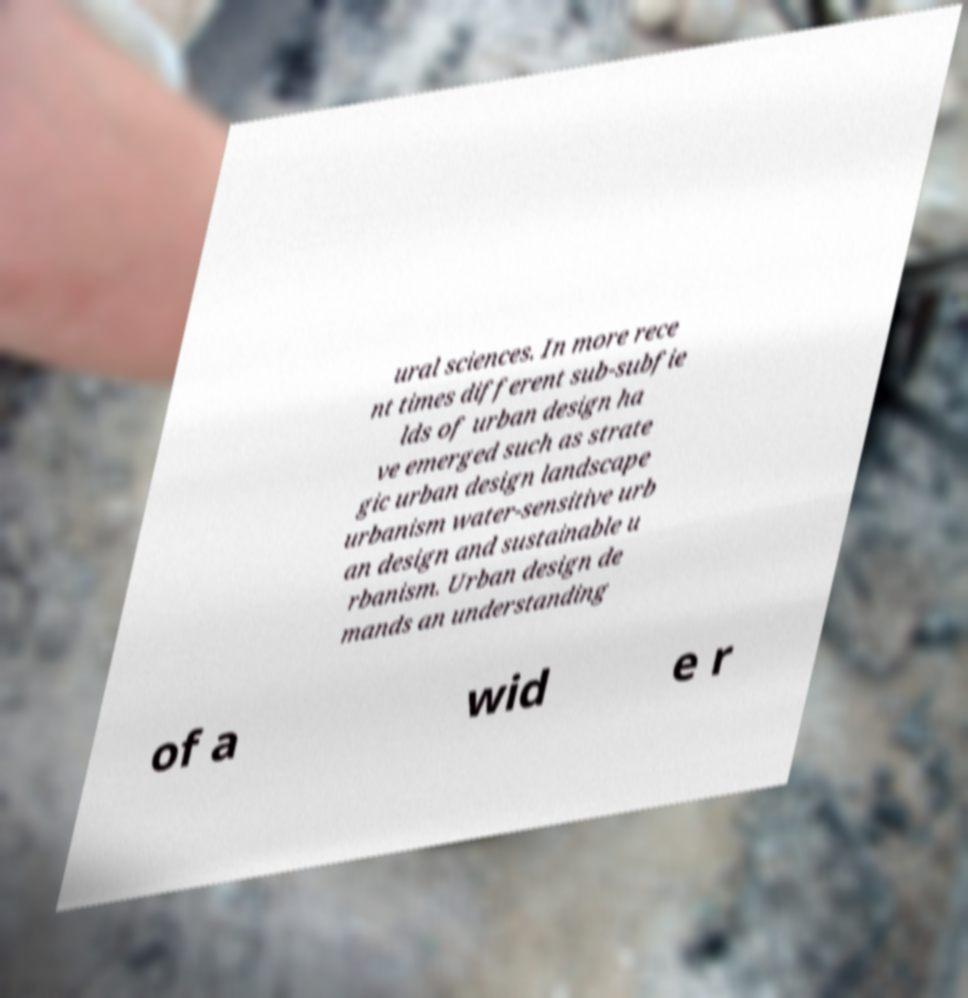Could you extract and type out the text from this image? ural sciences. In more rece nt times different sub-subfie lds of urban design ha ve emerged such as strate gic urban design landscape urbanism water-sensitive urb an design and sustainable u rbanism. Urban design de mands an understanding of a wid e r 